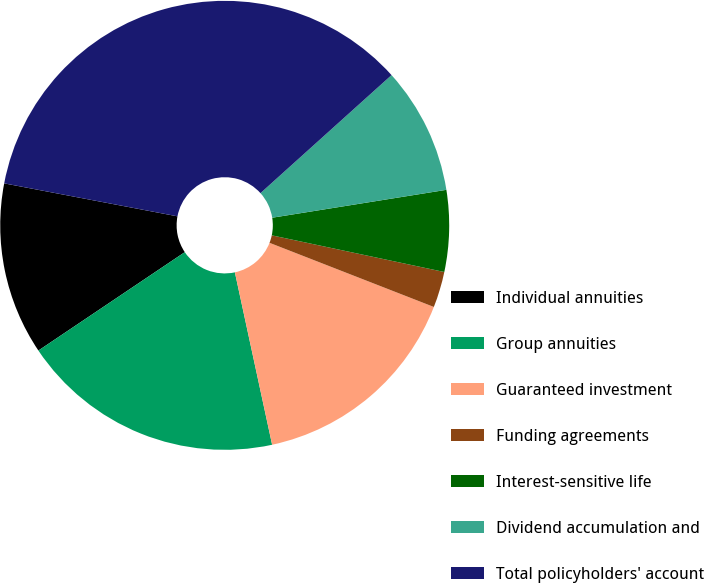Convert chart. <chart><loc_0><loc_0><loc_500><loc_500><pie_chart><fcel>Individual annuities<fcel>Group annuities<fcel>Guaranteed investment<fcel>Funding agreements<fcel>Interest-sensitive life<fcel>Dividend accumulation and<fcel>Total policyholders' account<nl><fcel>12.41%<fcel>18.97%<fcel>15.69%<fcel>2.59%<fcel>5.86%<fcel>9.14%<fcel>35.34%<nl></chart> 